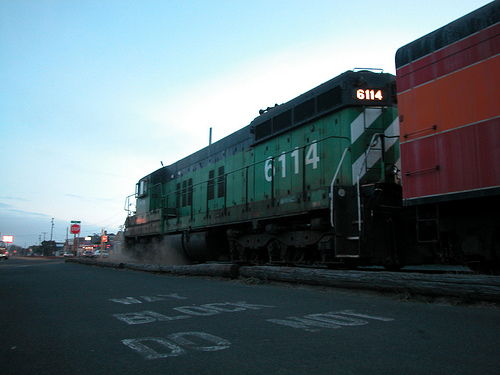Do you see both trains and cars? No, the image shows only a train and no cars are present. 